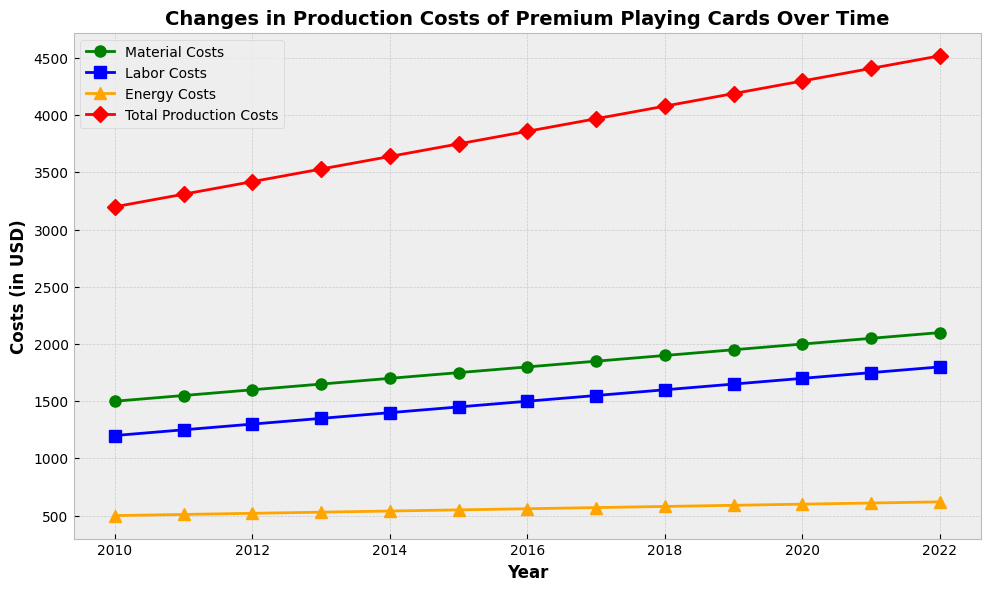What year had the highest total production costs? According to the line chart, the year with the highest red line value (Total Production Costs) is at the end of the time span. The highest total production costs occurred in 2022.
Answer: 2022 What is the difference in material costs between 2010 and 2022? Looking at the green line, the material costs in 2010 were $1500, and in 2022, they were $2100. The difference is $2100 - $1500 = $600.
Answer: $600 Which cost category showed the least increase over the years? By comparing the slopes of the green (Material Costs), blue (Labor Costs), and orange (Energy Costs) lines, we can see that the orange line (Energy Costs) increased the least over time.
Answer: Energy Costs How did total production costs change from 2014 to 2019? Referring to the red line, in 2014, total production costs were $3640, and in 2019, they were $4190. Therefore, the change is $4190 - $3640 = $550.
Answer: $550 In which year did labor costs and energy costs converge closest? By examining the distance between the blue (Labor Costs) and orange (Energy Costs) lines, the closest convergence appears around 2011 and 2012.
Answer: 2011-2012 What is the average annual increase in total production costs between 2010 and 2022? The total production costs in 2010 were $3200 and in 2022 were $4520. The overall increase is $4520 - $3200 = $1320, spread over 12 years. The average annual increase is $1320 / 12 ≈ $110.
Answer: $110 Which year had the steepest increase in material costs from the previous year? The steepest increase is the year-to-year change with the highest slope for the green line. Between 2021 and 2022, the material costs increased from $2050 to $2100, which is $50. Similarly, check year pairs and identify 2021-2022 as having the steepest increase.
Answer: 2021-2022 What was the total production cost in 2015 compared to the material costs in 2020? The total production cost in 2015 was $3750 and the material costs in 2020 were $2000. Comparing these, Total Production Costs in 2015 were $1750 higher than Material Costs in 2020: $3750 - $2000 = $1750.
Answer: $1750 Are labor costs always higher than energy costs throughout the years? By analyzing the blue (Labor Costs) and orange (Energy Costs) lines, it is evident that the blue line is always above the orange line, indicating that labor costs are indeed higher than energy costs throughout all the years.
Answer: Yes Which cost category had the most consistent increase over time? Observing the smoothness and parallelism of the lines, the green line (Material Costs) appears to rise at a relatively steady rate, implying a consistent increase compared to other categories.
Answer: Material Costs 